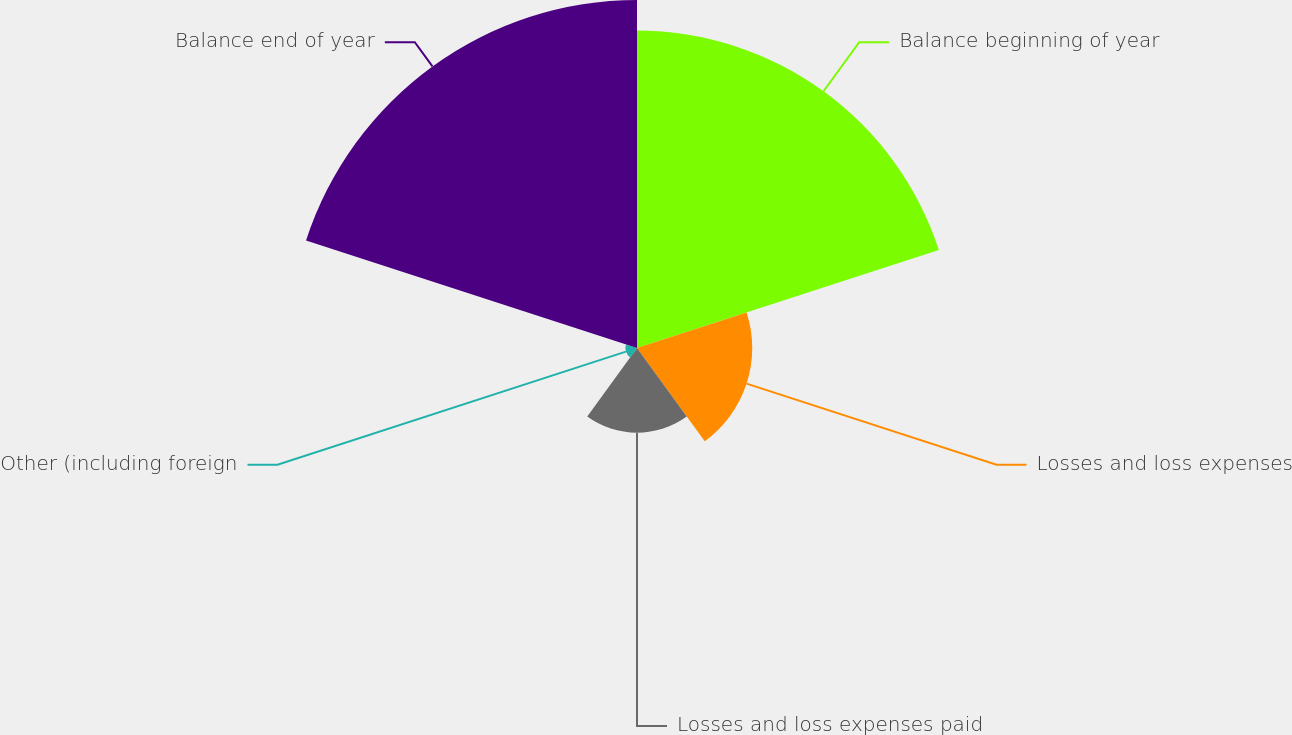Convert chart. <chart><loc_0><loc_0><loc_500><loc_500><pie_chart><fcel>Balance beginning of year<fcel>Losses and loss expenses<fcel>Losses and loss expenses paid<fcel>Other (including foreign<fcel>Balance end of year<nl><fcel>36.19%<fcel>13.14%<fcel>9.65%<fcel>1.33%<fcel>39.68%<nl></chart> 